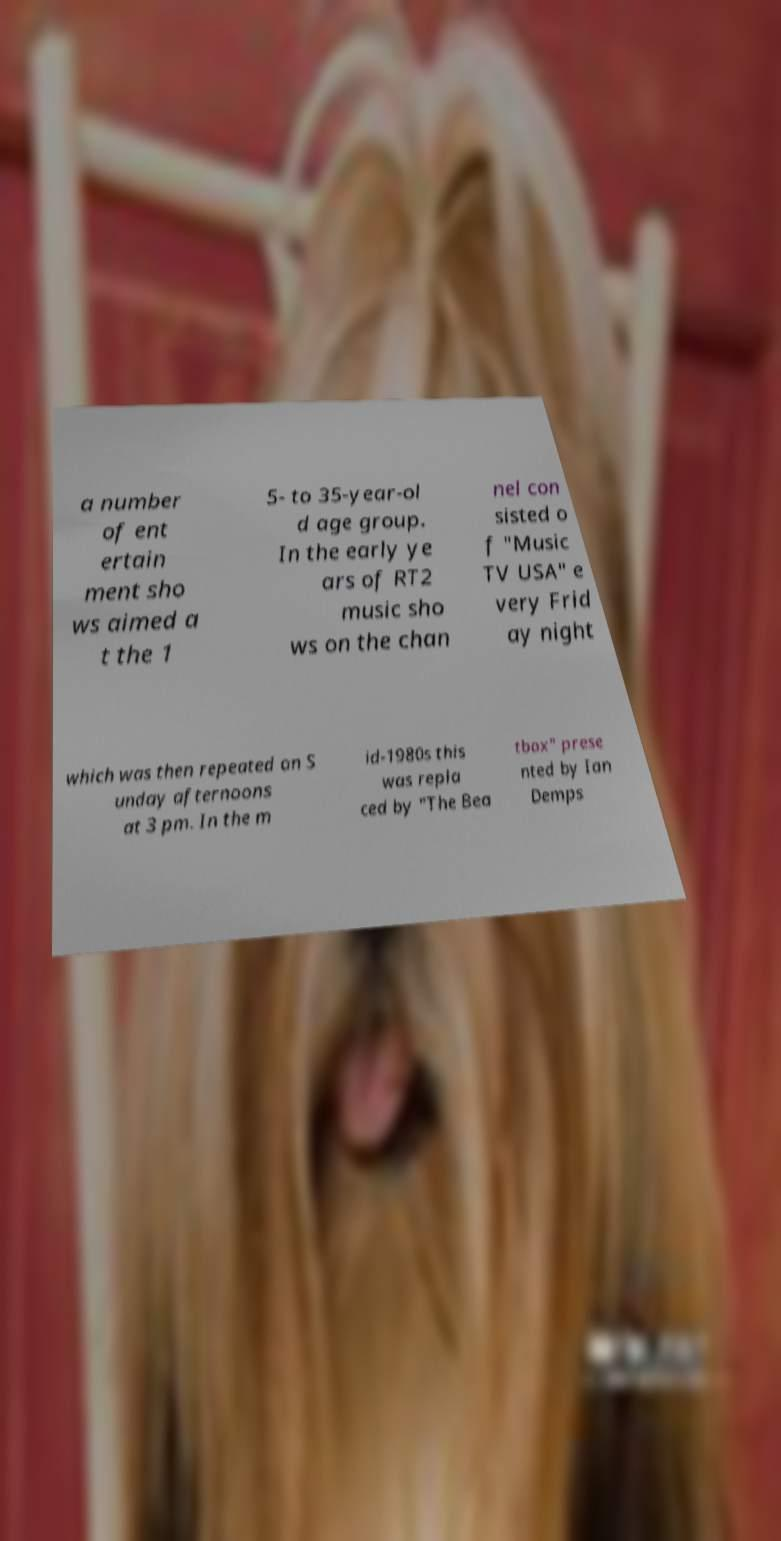I need the written content from this picture converted into text. Can you do that? a number of ent ertain ment sho ws aimed a t the 1 5- to 35-year-ol d age group. In the early ye ars of RT2 music sho ws on the chan nel con sisted o f "Music TV USA" e very Frid ay night which was then repeated on S unday afternoons at 3 pm. In the m id-1980s this was repla ced by "The Bea tbox" prese nted by Ian Demps 